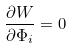<formula> <loc_0><loc_0><loc_500><loc_500>\frac { \partial W } { \partial \Phi _ { i } } = 0</formula> 